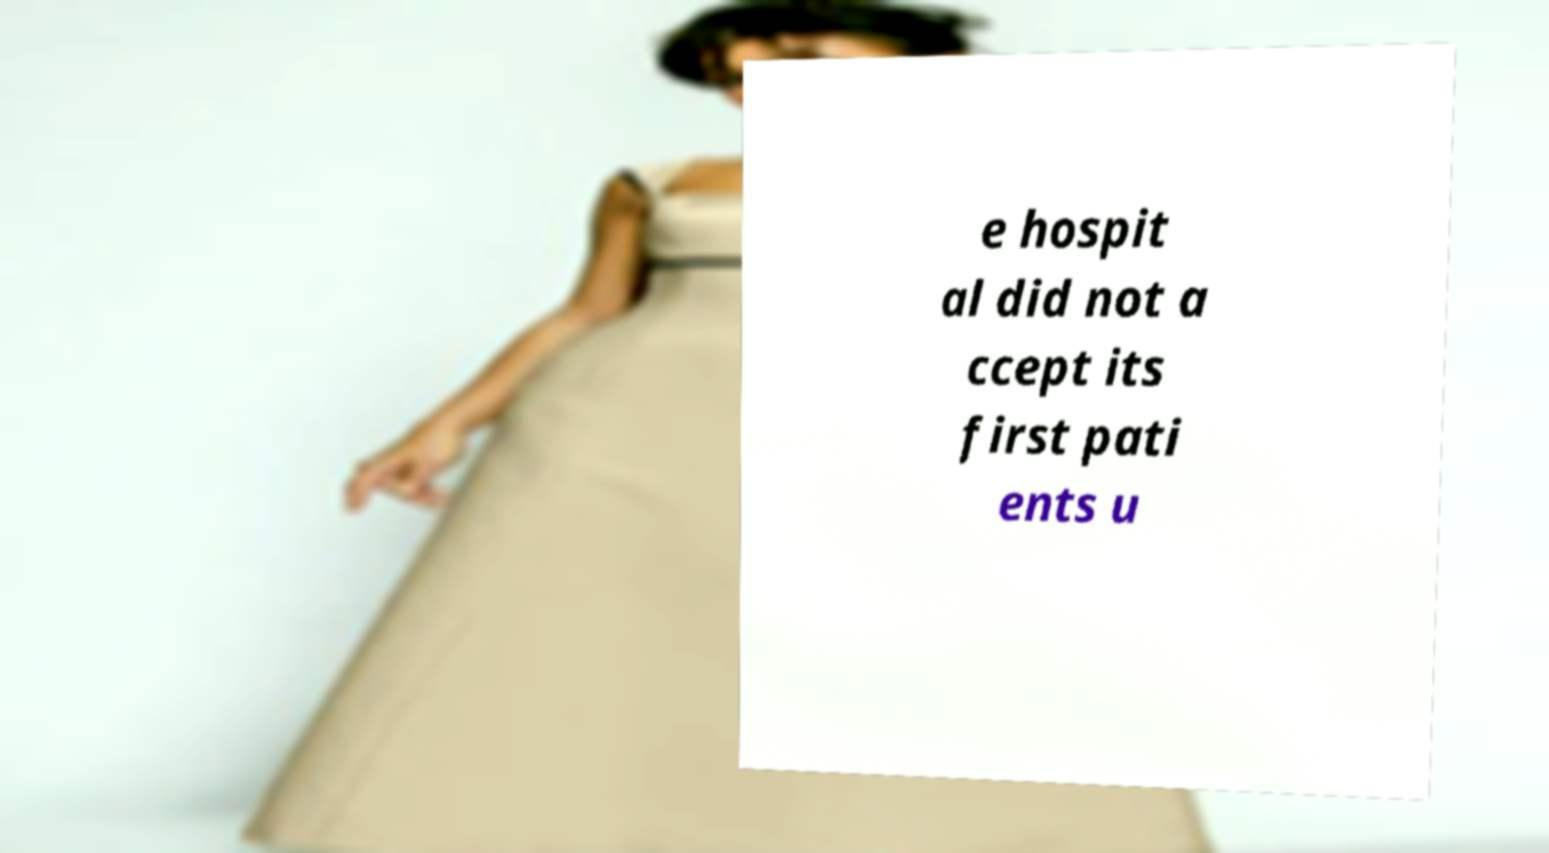Could you assist in decoding the text presented in this image and type it out clearly? e hospit al did not a ccept its first pati ents u 